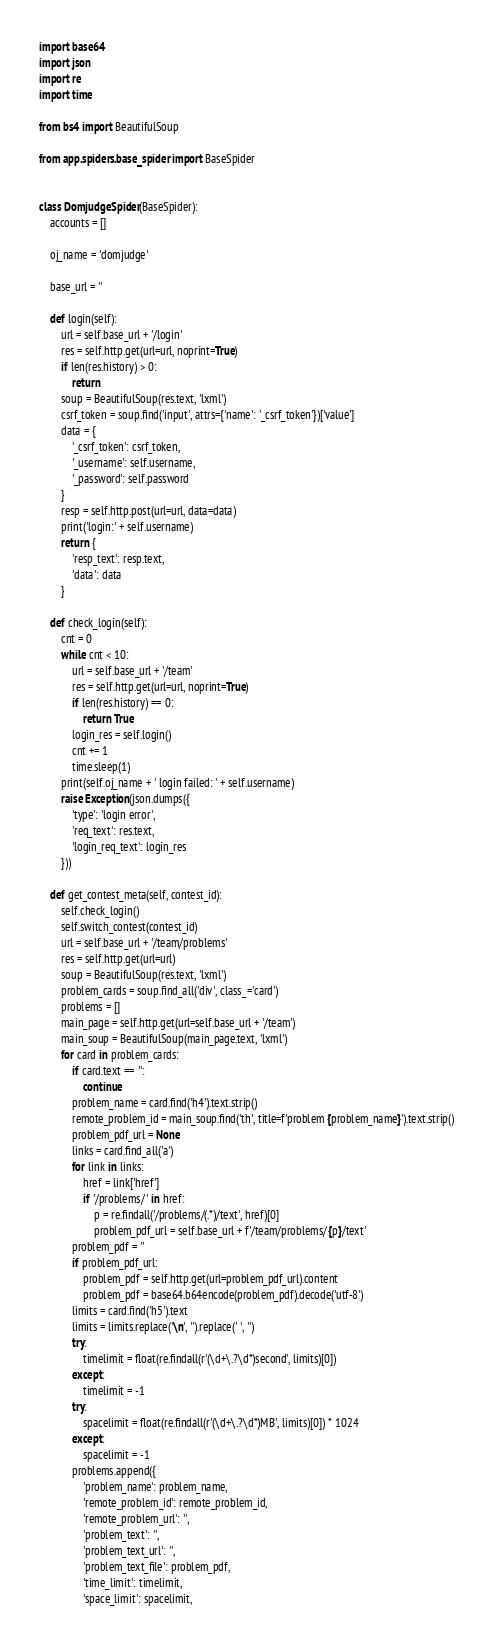Convert code to text. <code><loc_0><loc_0><loc_500><loc_500><_Python_>import base64
import json
import re
import time

from bs4 import BeautifulSoup

from app.spiders.base_spider import BaseSpider


class DomjudgeSpider(BaseSpider):
    accounts = []

    oj_name = 'domjudge'

    base_url = ''

    def login(self):
        url = self.base_url + '/login'
        res = self.http.get(url=url, noprint=True)
        if len(res.history) > 0:
            return
        soup = BeautifulSoup(res.text, 'lxml')
        csrf_token = soup.find('input', attrs={'name': '_csrf_token'})['value']
        data = {
            '_csrf_token': csrf_token,
            '_username': self.username,
            '_password': self.password
        }
        resp = self.http.post(url=url, data=data)
        print('login:' + self.username)
        return {
            'resp_text': resp.text,
            'data': data
        }

    def check_login(self):
        cnt = 0
        while cnt < 10:
            url = self.base_url + '/team'
            res = self.http.get(url=url, noprint=True)
            if len(res.history) == 0:
                return True
            login_res = self.login()
            cnt += 1
            time.sleep(1)
        print(self.oj_name + ' login failed: ' + self.username)
        raise Exception(json.dumps({
            'type': 'login error',
            'req_text': res.text,
            'login_req_text': login_res
        }))

    def get_contest_meta(self, contest_id):
        self.check_login()
        self.switch_contest(contest_id)
        url = self.base_url + '/team/problems'
        res = self.http.get(url=url)
        soup = BeautifulSoup(res.text, 'lxml')
        problem_cards = soup.find_all('div', class_='card')
        problems = []
        main_page = self.http.get(url=self.base_url + '/team')
        main_soup = BeautifulSoup(main_page.text, 'lxml')
        for card in problem_cards:
            if card.text == '':
                continue
            problem_name = card.find('h4').text.strip()
            remote_problem_id = main_soup.find('th', title=f'problem {problem_name}').text.strip()
            problem_pdf_url = None
            links = card.find_all('a')
            for link in links:
                href = link['href']
                if '/problems/' in href:
                    p = re.findall('/problems/(.*)/text', href)[0]
                    problem_pdf_url = self.base_url + f'/team/problems/{p}/text'
            problem_pdf = ''
            if problem_pdf_url:
                problem_pdf = self.http.get(url=problem_pdf_url).content
                problem_pdf = base64.b64encode(problem_pdf).decode('utf-8')
            limits = card.find('h5').text
            limits = limits.replace('\n', '').replace(' ', '')
            try:
                timelimit = float(re.findall(r'(\d+\.?\d*)second', limits)[0])
            except:
                timelimit = -1
            try:
                spacelimit = float(re.findall(r'(\d+\.?\d*)MB', limits)[0]) * 1024
            except:
                spacelimit = -1
            problems.append({
                'problem_name': problem_name,
                'remote_problem_id': remote_problem_id,
                'remote_problem_url': '',
                'problem_text': '',
                'problem_text_url': '',
                'problem_text_file': problem_pdf,
                'time_limit': timelimit,
                'space_limit': spacelimit,</code> 